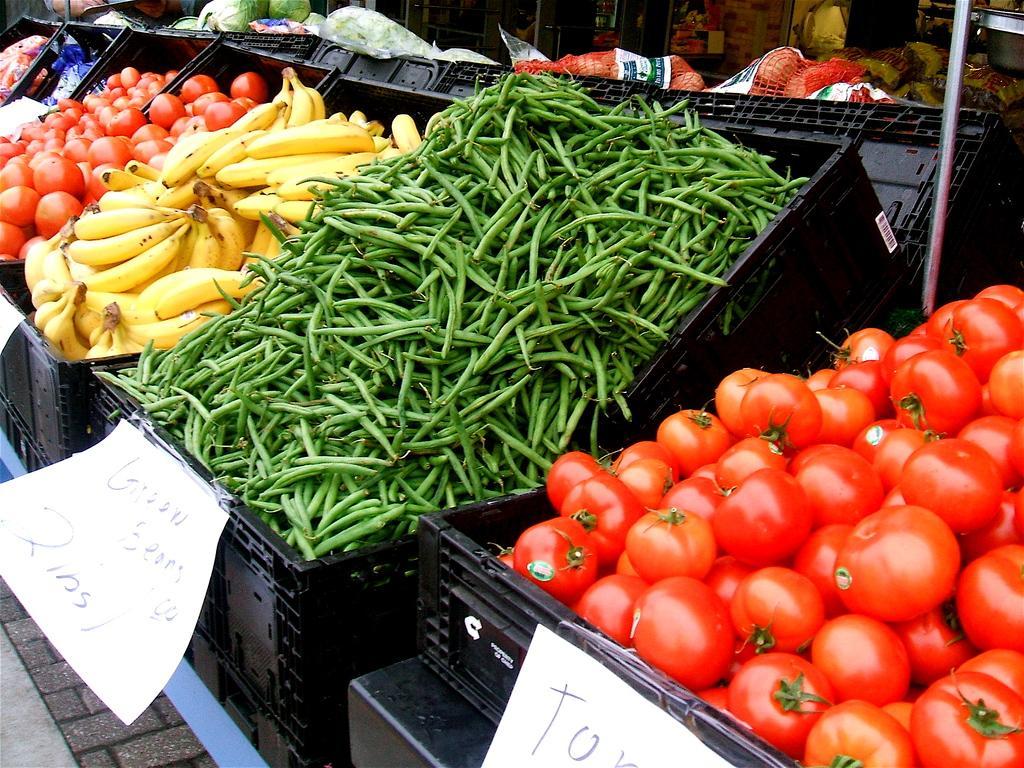Describe this image in one or two sentences. This pictures looks like a market. We see tomatoes, beans, Bananas and couple of other fruits and vegetables in the baskets and we see price boards hanging to the baskets. 